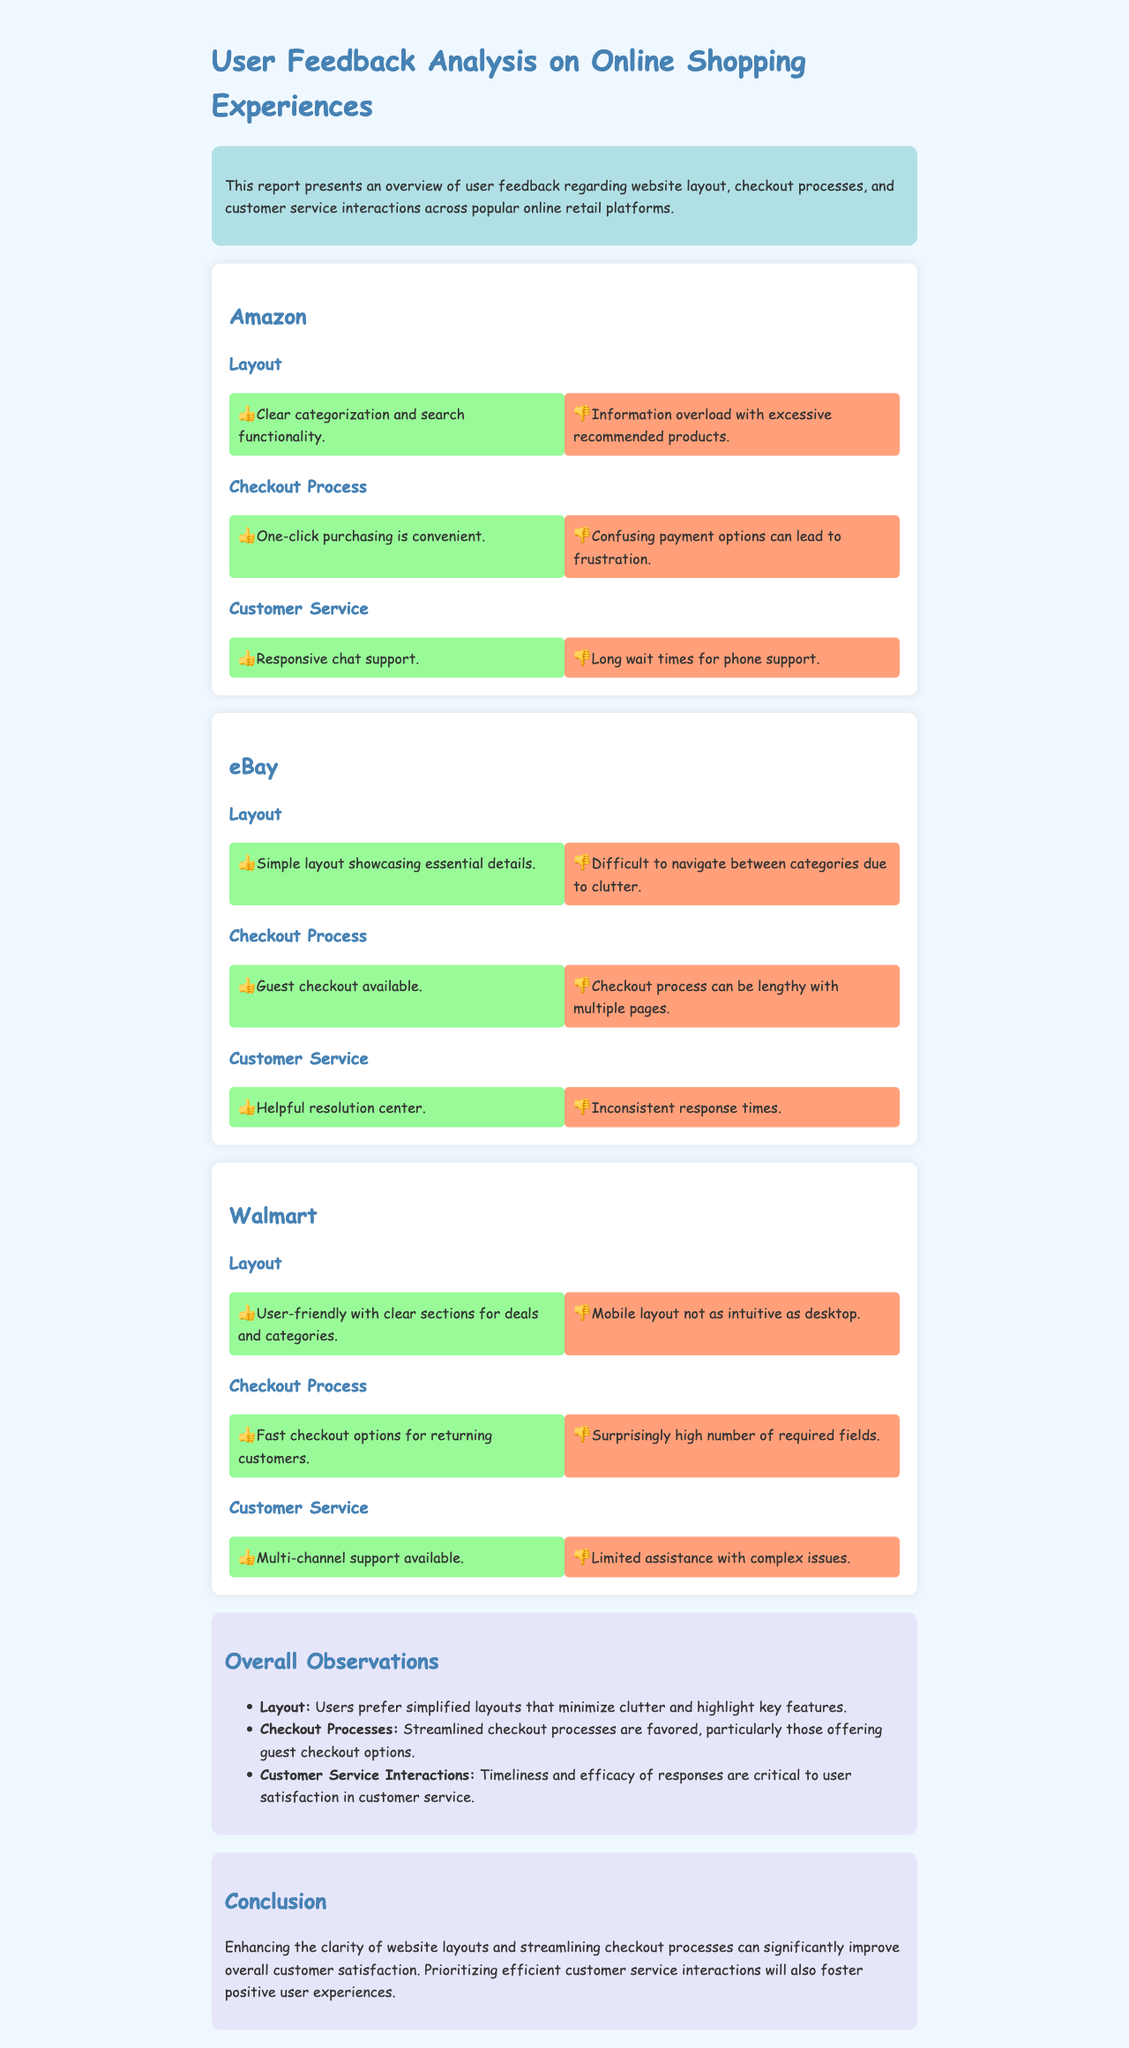What is the primary focus of the report? The report presents an overview of user feedback regarding website layout, checkout processes, and customer service interactions across popular online retail platforms.
Answer: user feedback What are the positive aspects of Amazon's customer service? The positive aspects are listed in the customer service section for Amazon, detailing user feedback on responsiveness.
Answer: Responsive chat support What is a negative feedback point about eBay's layout? The layout negative feedback highlights issues specifically mentioned under eBay's layout section, regarding navigation.
Answer: Difficult to navigate between categories due to clutter What feature is highlighted as convenient in Amazon's checkout process? The positive feedback in the checkout process section for Amazon points out a specific feature considered convenient by users.
Answer: One-click purchasing How does Walmart's mobile layout compare to its desktop layout? The negative feedback under Walmart's layout section indicates how users feel about the mobile experience compared to desktop.
Answer: Mobile layout not as intuitive as desktop What is a preferred feature in checkout processes according to users? The report discusses user preferences in checkout processes, highlighting a specific feature that users favor.
Answer: Guest checkout options Which platform has a lengthy checkout process mentioned in user feedback? The checkout process feedback points towards user experiences specifically highlighted in eBay's checkout section.
Answer: eBay What common issue is reported for customer service interactions? The overall observations list a critical aspect that affects user satisfaction in customer service feedback across platforms.
Answer: Timeliness What color is used for positive feedback sections in the report? The style of the document describes the design elements, including the color used for positive feedback categories.
Answer: Light green 